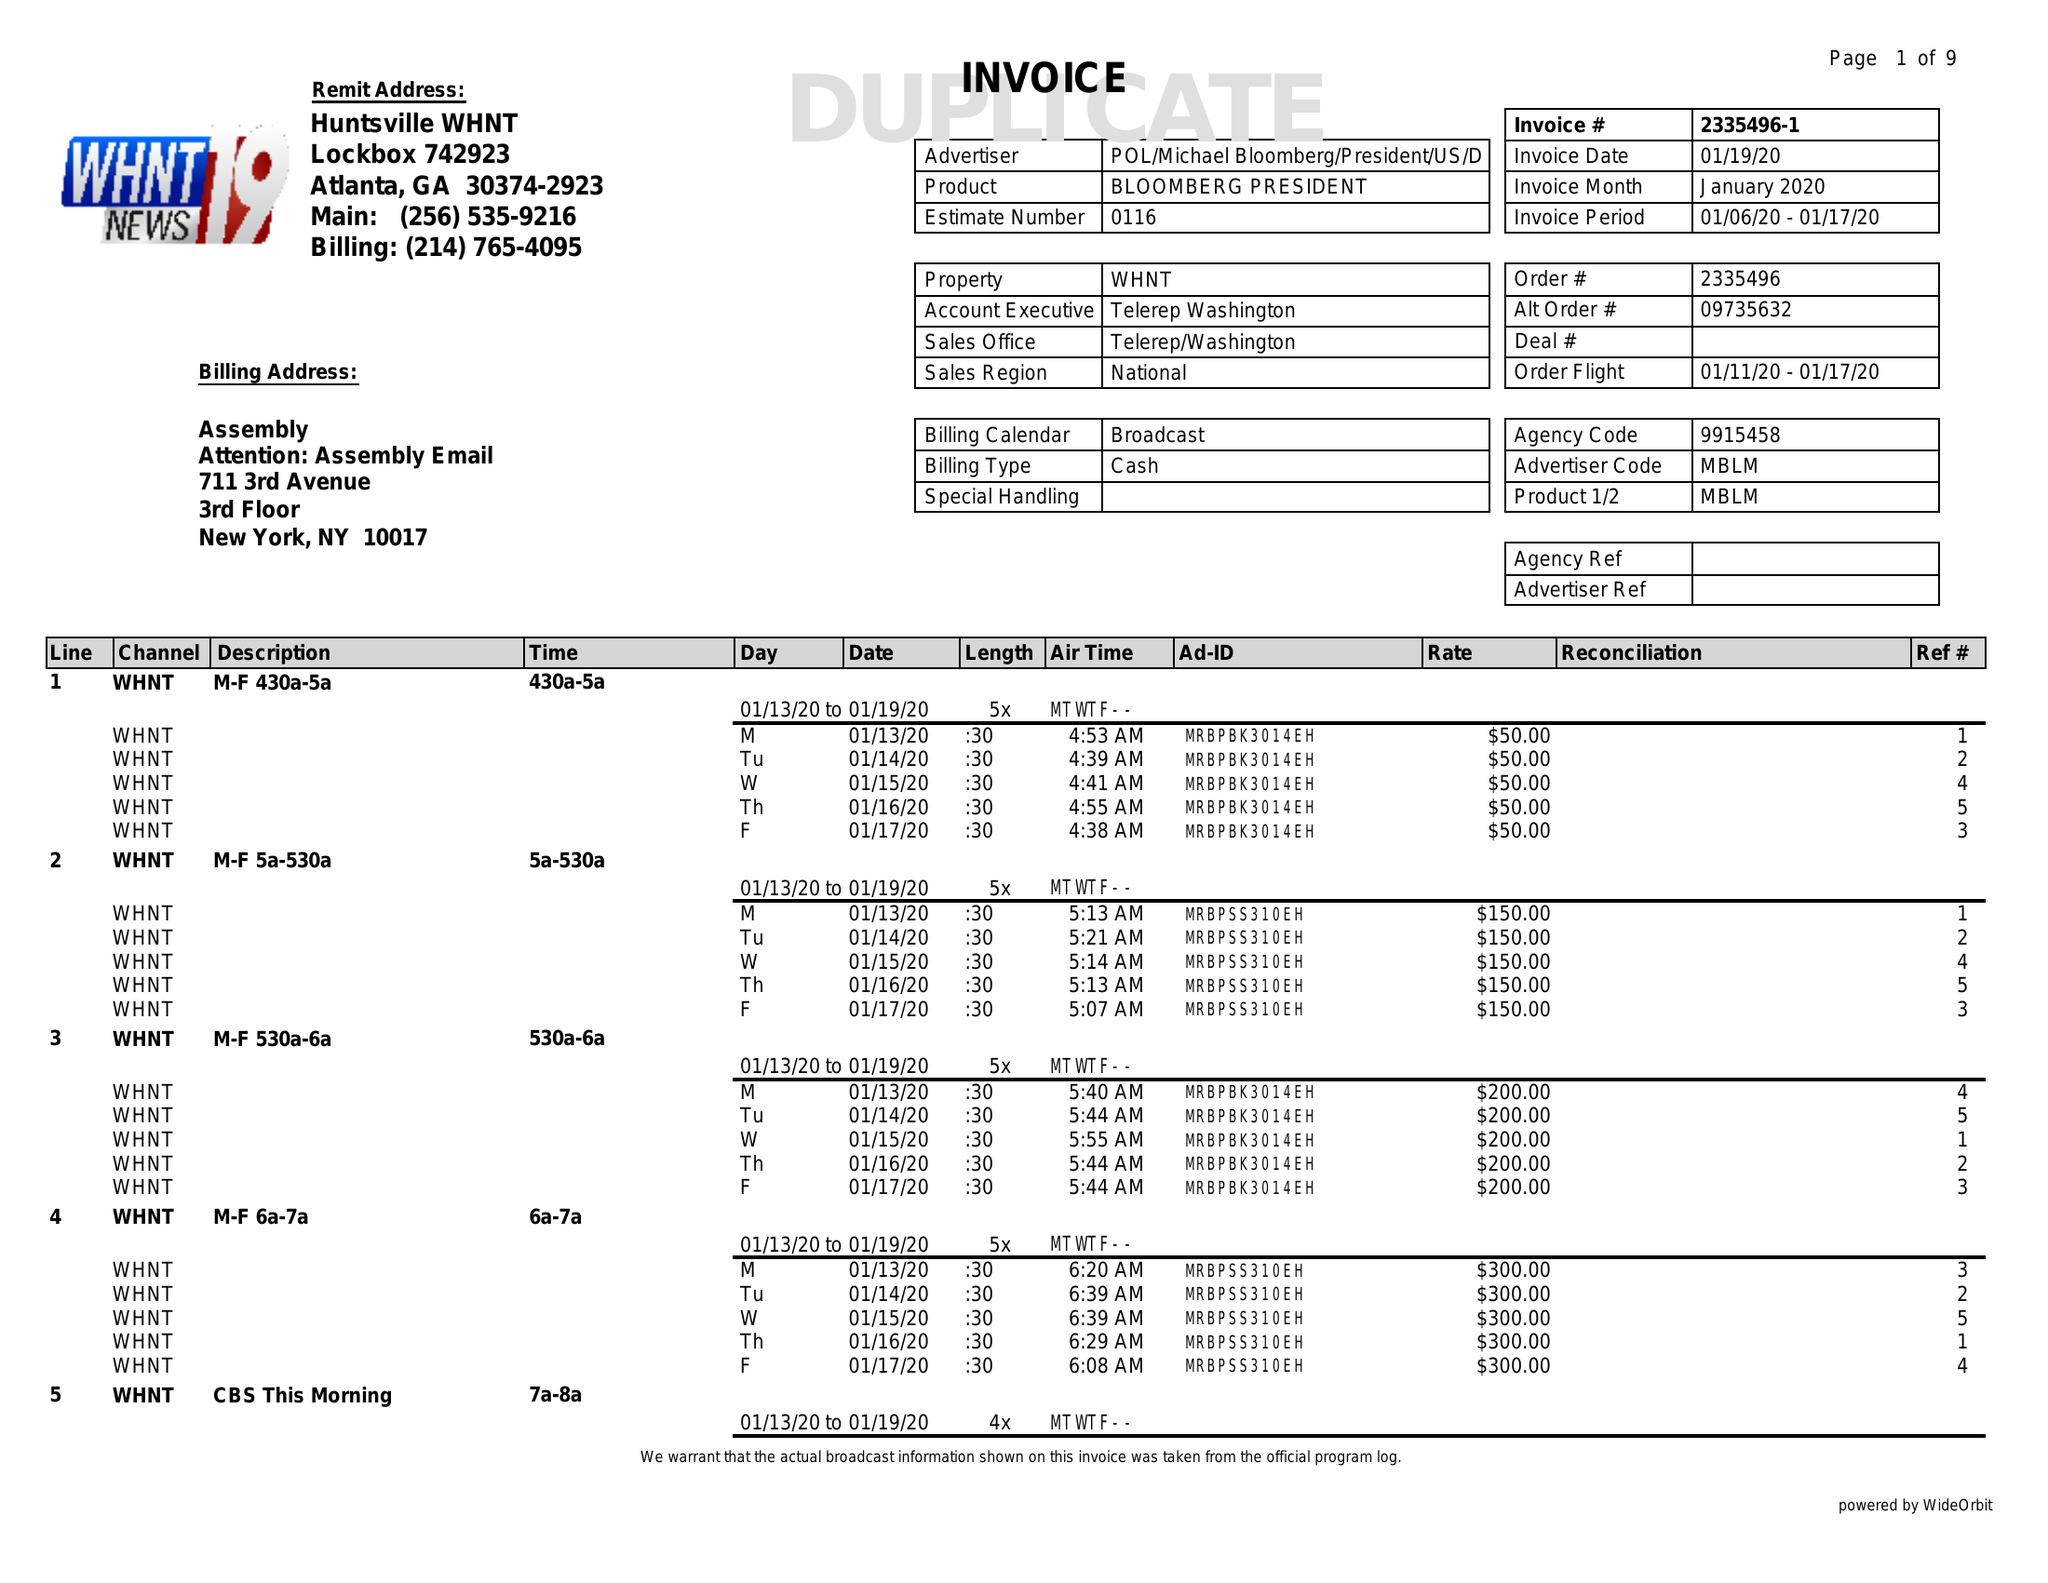What is the value for the gross_amount?
Answer the question using a single word or phrase. 39650.00 